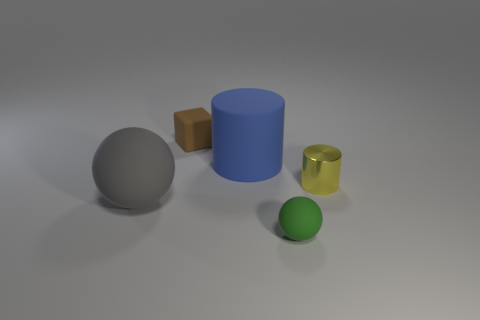What number of small objects are both in front of the blue thing and behind the small green object?
Provide a short and direct response. 1. What number of tiny metal objects have the same shape as the big gray rubber thing?
Your answer should be compact. 0. There is a thing that is right of the small rubber object that is in front of the blue thing; what is its color?
Your answer should be very brief. Yellow. Does the gray thing have the same shape as the tiny object that is on the left side of the small sphere?
Ensure brevity in your answer.  No. There is a big thing that is behind the big matte object that is left of the small matte object that is behind the blue matte cylinder; what is its material?
Make the answer very short. Rubber. Is there a sphere of the same size as the block?
Your answer should be compact. Yes. The gray sphere that is made of the same material as the tiny brown cube is what size?
Give a very brief answer. Large. There is a brown matte thing; what shape is it?
Your answer should be very brief. Cube. Are the large gray sphere and the sphere that is right of the brown block made of the same material?
Keep it short and to the point. Yes. What number of objects are big brown spheres or balls?
Offer a very short reply. 2. 